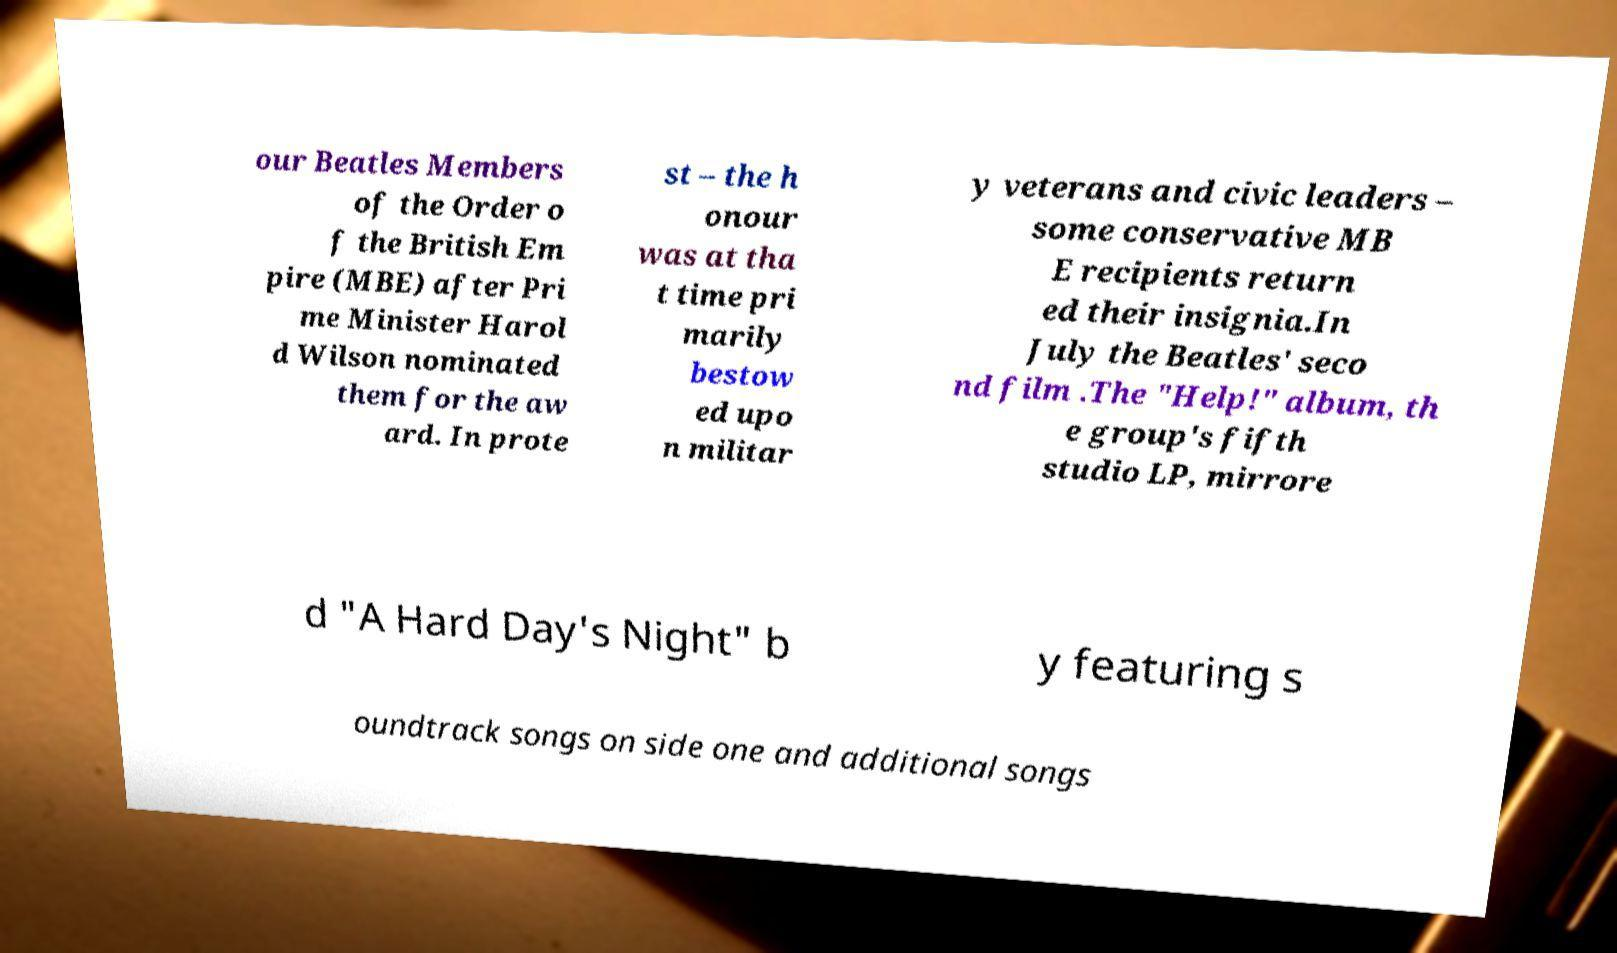Can you read and provide the text displayed in the image?This photo seems to have some interesting text. Can you extract and type it out for me? our Beatles Members of the Order o f the British Em pire (MBE) after Pri me Minister Harol d Wilson nominated them for the aw ard. In prote st – the h onour was at tha t time pri marily bestow ed upo n militar y veterans and civic leaders – some conservative MB E recipients return ed their insignia.In July the Beatles' seco nd film .The "Help!" album, th e group's fifth studio LP, mirrore d "A Hard Day's Night" b y featuring s oundtrack songs on side one and additional songs 